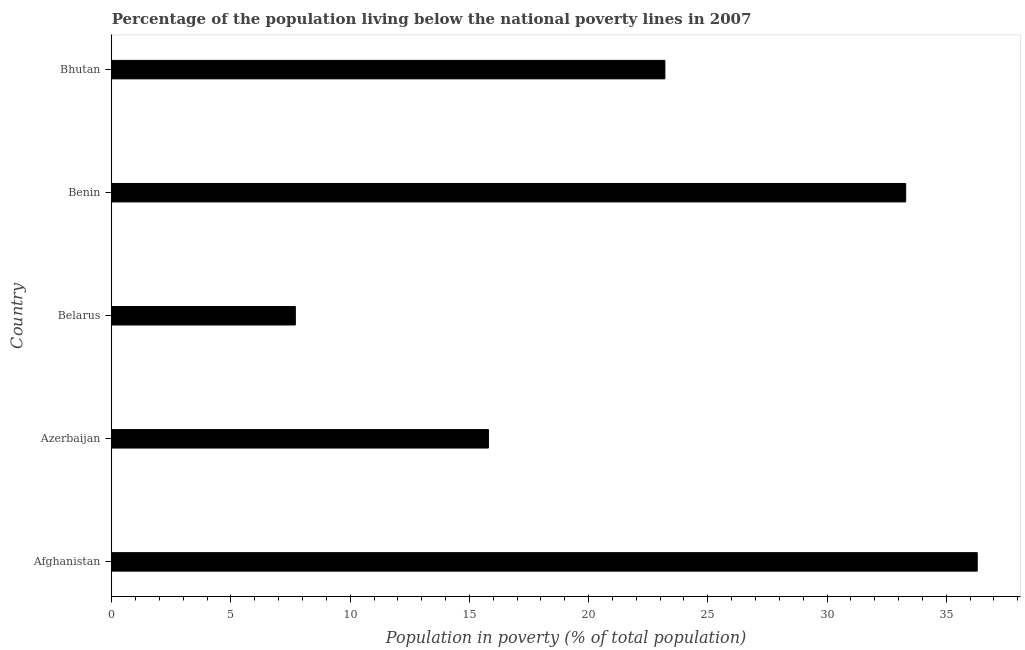What is the title of the graph?
Offer a very short reply. Percentage of the population living below the national poverty lines in 2007. What is the label or title of the X-axis?
Provide a short and direct response. Population in poverty (% of total population). What is the label or title of the Y-axis?
Give a very brief answer. Country. What is the percentage of population living below poverty line in Afghanistan?
Your answer should be compact. 36.3. Across all countries, what is the maximum percentage of population living below poverty line?
Provide a short and direct response. 36.3. In which country was the percentage of population living below poverty line maximum?
Make the answer very short. Afghanistan. In which country was the percentage of population living below poverty line minimum?
Your answer should be very brief. Belarus. What is the sum of the percentage of population living below poverty line?
Your answer should be compact. 116.3. What is the difference between the percentage of population living below poverty line in Azerbaijan and Benin?
Provide a succinct answer. -17.5. What is the average percentage of population living below poverty line per country?
Provide a short and direct response. 23.26. What is the median percentage of population living below poverty line?
Offer a very short reply. 23.2. What is the ratio of the percentage of population living below poverty line in Afghanistan to that in Belarus?
Offer a very short reply. 4.71. Is the percentage of population living below poverty line in Azerbaijan less than that in Belarus?
Offer a terse response. No. Is the difference between the percentage of population living below poverty line in Azerbaijan and Bhutan greater than the difference between any two countries?
Your answer should be very brief. No. What is the difference between the highest and the second highest percentage of population living below poverty line?
Your response must be concise. 3. What is the difference between the highest and the lowest percentage of population living below poverty line?
Offer a very short reply. 28.6. In how many countries, is the percentage of population living below poverty line greater than the average percentage of population living below poverty line taken over all countries?
Offer a very short reply. 2. How many bars are there?
Your answer should be compact. 5. How many countries are there in the graph?
Ensure brevity in your answer.  5. What is the Population in poverty (% of total population) of Afghanistan?
Provide a succinct answer. 36.3. What is the Population in poverty (% of total population) in Benin?
Your answer should be compact. 33.3. What is the Population in poverty (% of total population) of Bhutan?
Your answer should be compact. 23.2. What is the difference between the Population in poverty (% of total population) in Afghanistan and Azerbaijan?
Keep it short and to the point. 20.5. What is the difference between the Population in poverty (% of total population) in Afghanistan and Belarus?
Provide a short and direct response. 28.6. What is the difference between the Population in poverty (% of total population) in Afghanistan and Benin?
Your answer should be compact. 3. What is the difference between the Population in poverty (% of total population) in Afghanistan and Bhutan?
Make the answer very short. 13.1. What is the difference between the Population in poverty (% of total population) in Azerbaijan and Belarus?
Your answer should be very brief. 8.1. What is the difference between the Population in poverty (% of total population) in Azerbaijan and Benin?
Your answer should be very brief. -17.5. What is the difference between the Population in poverty (% of total population) in Belarus and Benin?
Provide a short and direct response. -25.6. What is the difference between the Population in poverty (% of total population) in Belarus and Bhutan?
Your answer should be compact. -15.5. What is the difference between the Population in poverty (% of total population) in Benin and Bhutan?
Your response must be concise. 10.1. What is the ratio of the Population in poverty (% of total population) in Afghanistan to that in Azerbaijan?
Make the answer very short. 2.3. What is the ratio of the Population in poverty (% of total population) in Afghanistan to that in Belarus?
Offer a very short reply. 4.71. What is the ratio of the Population in poverty (% of total population) in Afghanistan to that in Benin?
Keep it short and to the point. 1.09. What is the ratio of the Population in poverty (% of total population) in Afghanistan to that in Bhutan?
Give a very brief answer. 1.56. What is the ratio of the Population in poverty (% of total population) in Azerbaijan to that in Belarus?
Your answer should be very brief. 2.05. What is the ratio of the Population in poverty (% of total population) in Azerbaijan to that in Benin?
Offer a terse response. 0.47. What is the ratio of the Population in poverty (% of total population) in Azerbaijan to that in Bhutan?
Your response must be concise. 0.68. What is the ratio of the Population in poverty (% of total population) in Belarus to that in Benin?
Offer a terse response. 0.23. What is the ratio of the Population in poverty (% of total population) in Belarus to that in Bhutan?
Keep it short and to the point. 0.33. What is the ratio of the Population in poverty (% of total population) in Benin to that in Bhutan?
Provide a short and direct response. 1.44. 